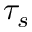<formula> <loc_0><loc_0><loc_500><loc_500>\tau _ { s }</formula> 